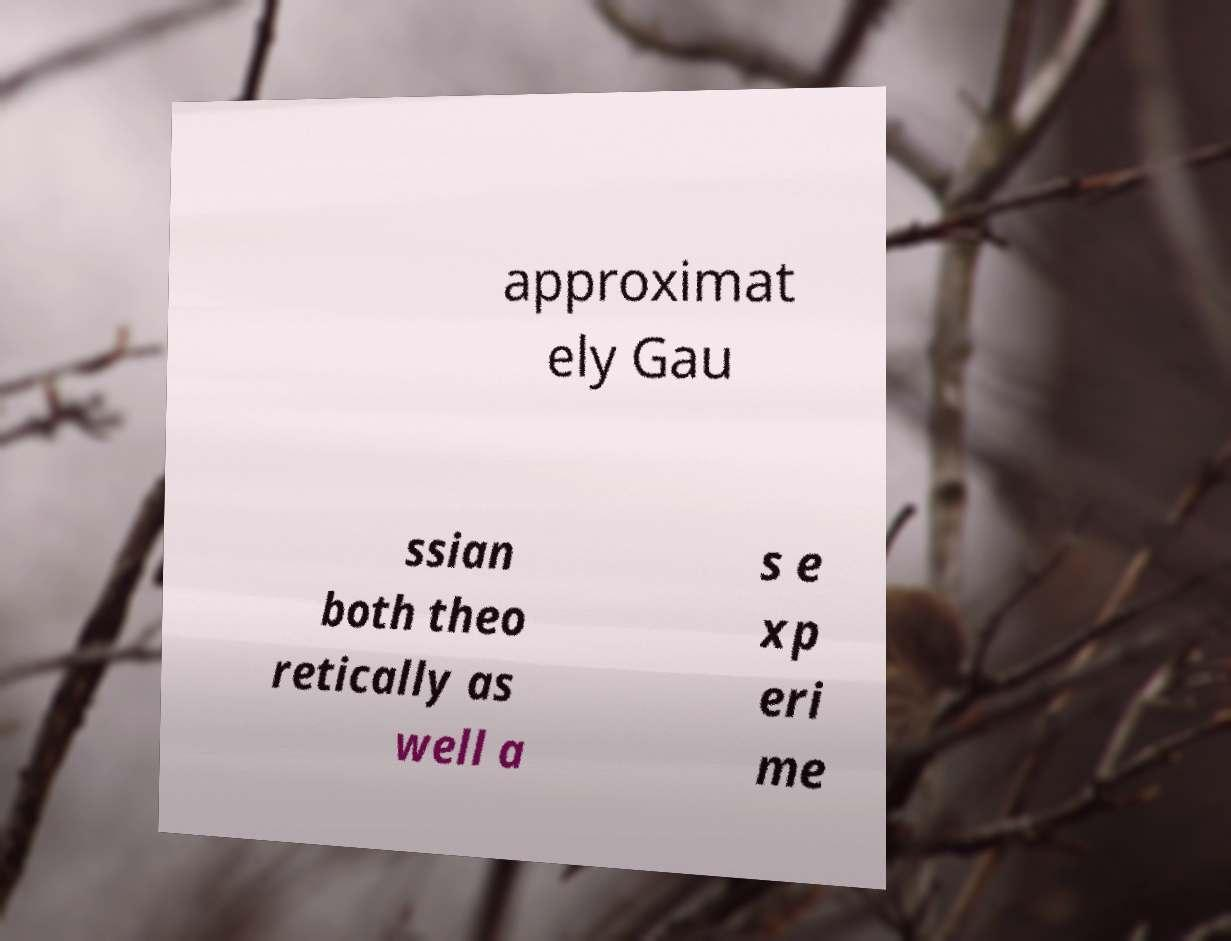Please identify and transcribe the text found in this image. approximat ely Gau ssian both theo retically as well a s e xp eri me 